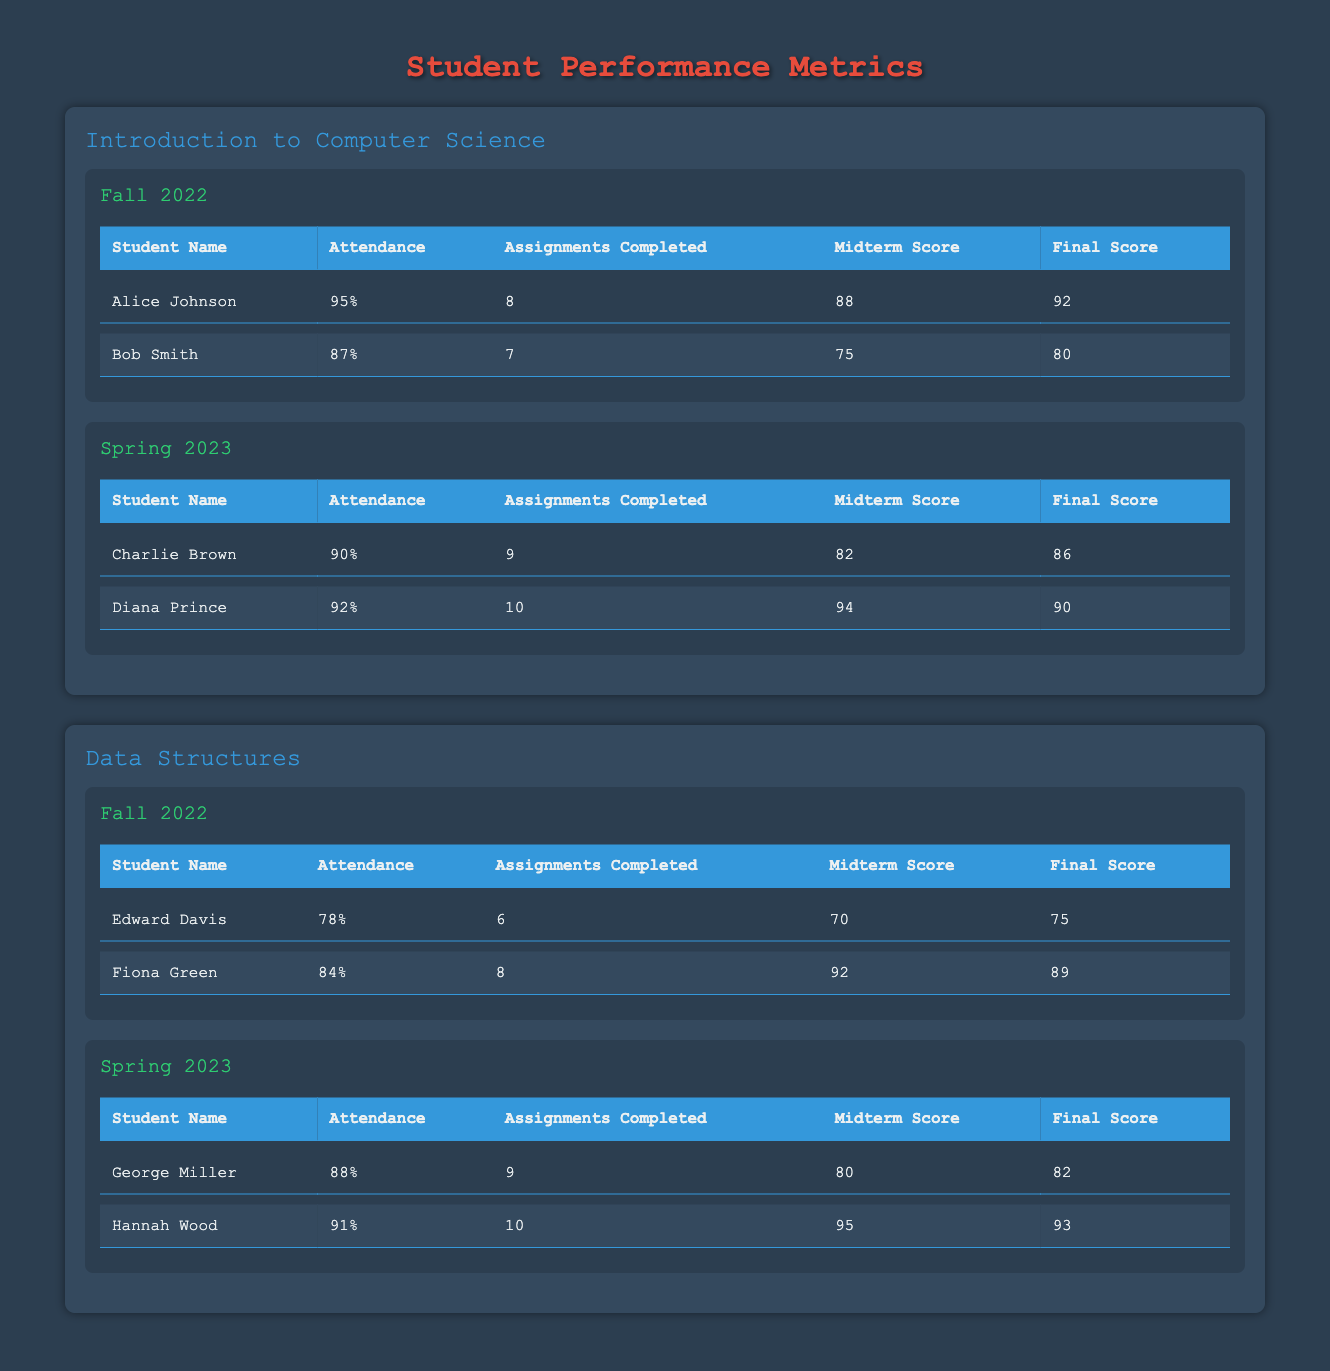What is the attendance percentage of Alice Johnson? Alice Johnson's attendance percentage can be found directly in the table under her performance metrics in the "Fall 2022" semester of the "Introduction to Computer Science" course. It is listed as 95%.
Answer: 95% Who had the highest final score in Spring 2023 for the "Data Structures" course? In the "Data Structures" course for Spring 2023, the final scores are as follows: George Miller has 82 and Hannah Wood has 93. Comparing these scores, Hannah Wood has the highest final score of 93.
Answer: 93 What is the average midterm score for the students in the "Introduction to Computer Science" course for Fall 2022? To find the average midterm score for Fall 2022, we take the midterm scores of Alice Johnson (88) and Bob Smith (75). The sum is 88 + 75 = 163. There are 2 students, so the average is 163 / 2 = 81.5.
Answer: 81.5 Did any student in the "Data Structures" course achieve an attendance of 90% or higher in Fall 2022? Looking at the attendance percentages for Fall 2022, Edward Davis has 78% and Fiona Green has 84%. Both percentages are below 90%, indicating that no student achieved 90% or higher in that semester.
Answer: No What is the total number of assignments completed by all students in the "Introduction to Computer Science" course during Spring 2023? In Spring 2023, Charlie Brown completed 9 assignments and Diana Prince completed 10 assignments. Adding these gives a total of 9 + 10 = 19 assignments completed by all students in that course and semester.
Answer: 19 Which semester had the lowest attendance among students in the "Data Structures" course? The attendance percentages in Fall 2022 show Edward Davis at 78% and Fiona Green at 84%. In Spring 2023, George Miller is at 88% and Hannah Wood at 91%. The lowest attendance is Edward Davis's 78% in the Fall 2022 semester.
Answer: Fall 2022 What is the difference between the maximum and minimum final scores in the Spring 2023 "Introduction to Computer Science" semester? In Spring 2023, Charlie Brown's final score is 86 and Diana Prince's final score is 90. The maximum is 90 and the minimum is 86. The difference is 90 - 86 = 4.
Answer: 4 Who had the best overall attendance score across both semesters for the "Introduction to Computer Science" course? In Fall 2022, Alice Johnson had 95% attendance and in Spring 2023, Charlie Brown had 90% and Diana Prince had 92%. Among them, Alice Johnson has the highest attendance score of 95%, making her the student with the best overall attendance in that course.
Answer: Alice Johnson 